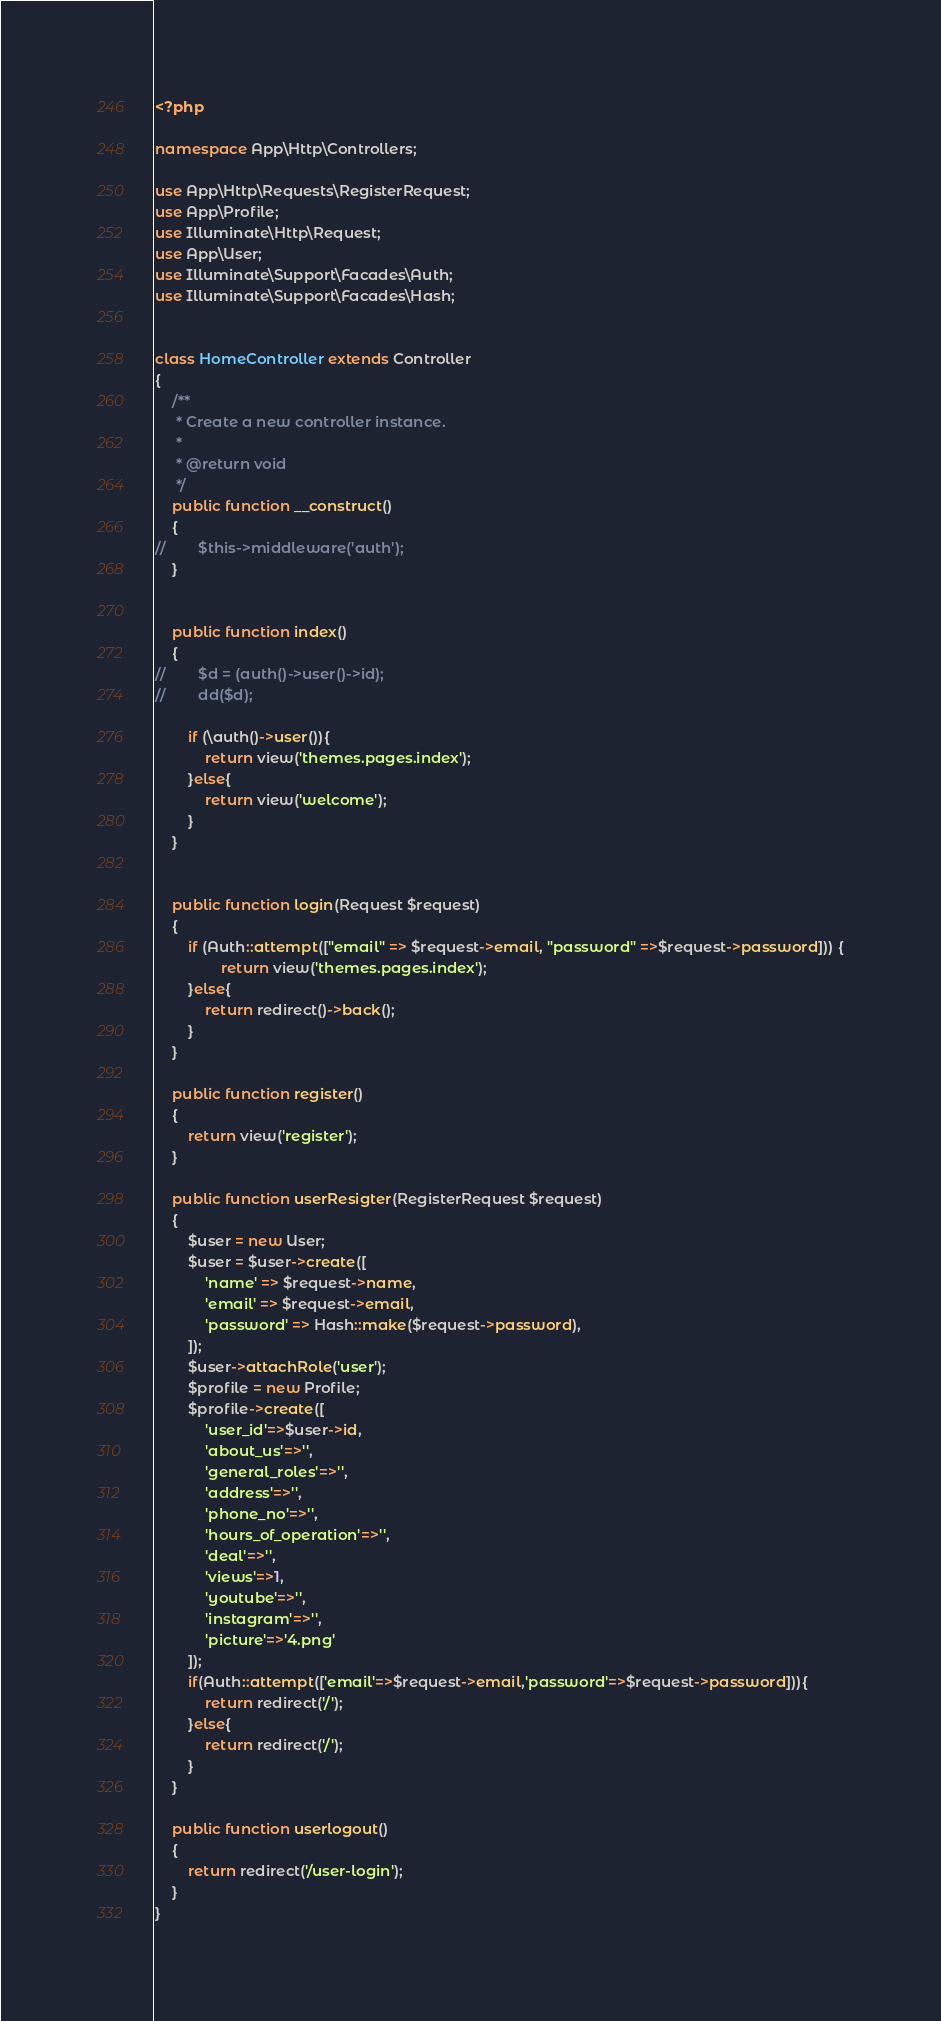<code> <loc_0><loc_0><loc_500><loc_500><_PHP_><?php

namespace App\Http\Controllers;

use App\Http\Requests\RegisterRequest;
use App\Profile;
use Illuminate\Http\Request;
use App\User;
use Illuminate\Support\Facades\Auth;
use Illuminate\Support\Facades\Hash;


class HomeController extends Controller
{
    /**
     * Create a new controller instance.
     *
     * @return void
     */
    public function __construct()
    {
//        $this->middleware('auth');
    }


    public function index()
    {
//        $d = (auth()->user()->id);
//        dd($d);

        if (\auth()->user()){
            return view('themes.pages.index');
        }else{
            return view('welcome');
        }
    }


    public function login(Request $request)
    {
        if (Auth::attempt(["email" => $request->email, "password" =>$request->password])) {
                return view('themes.pages.index');
        }else{
            return redirect()->back();
        }
    }

    public function register()
    {
        return view('register');
    }

    public function userResigter(RegisterRequest $request)
    {
        $user = new User;
        $user = $user->create([
            'name' => $request->name,
            'email' => $request->email,
            'password' => Hash::make($request->password),
        ]);
        $user->attachRole('user');
        $profile = new Profile;
        $profile->create([
            'user_id'=>$user->id,
            'about_us'=>'',
            'general_roles'=>'',
            'address'=>'',
            'phone_no'=>'',
            'hours_of_operation'=>'',
            'deal'=>'',
            'views'=>1,
            'youtube'=>'',
            'instagram'=>'',
            'picture'=>'4.png'
        ]);
        if(Auth::attempt(['email'=>$request->email,'password'=>$request->password])){
            return redirect('/');
        }else{
            return redirect('/');
        }
    }

    public function userlogout()
    {
        return redirect('/user-login');
    }
}
</code> 